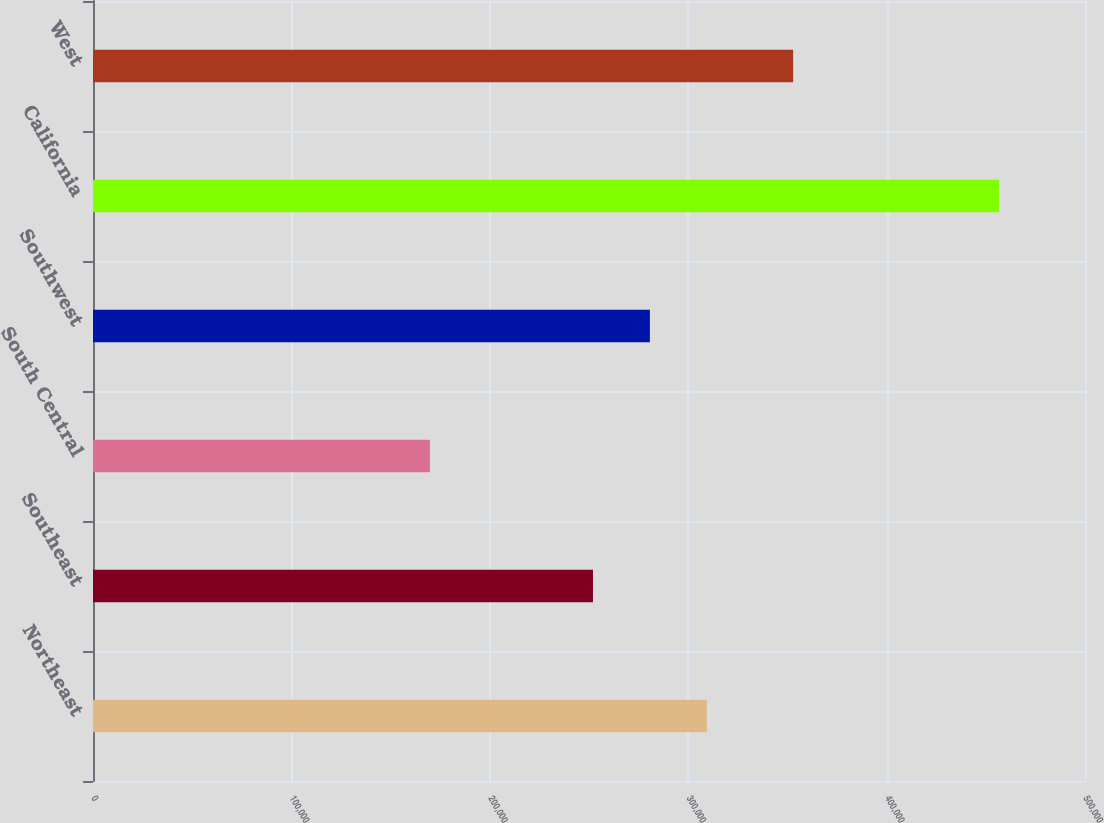Convert chart. <chart><loc_0><loc_0><loc_500><loc_500><bar_chart><fcel>Northeast<fcel>Southeast<fcel>South Central<fcel>Southwest<fcel>California<fcel>West<nl><fcel>309380<fcel>252000<fcel>169800<fcel>280690<fcel>456700<fcel>352900<nl></chart> 